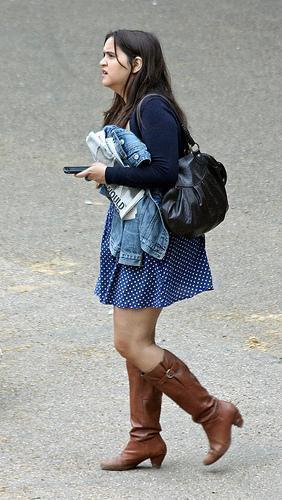How many people are in the photo?
Give a very brief answer. 1. 